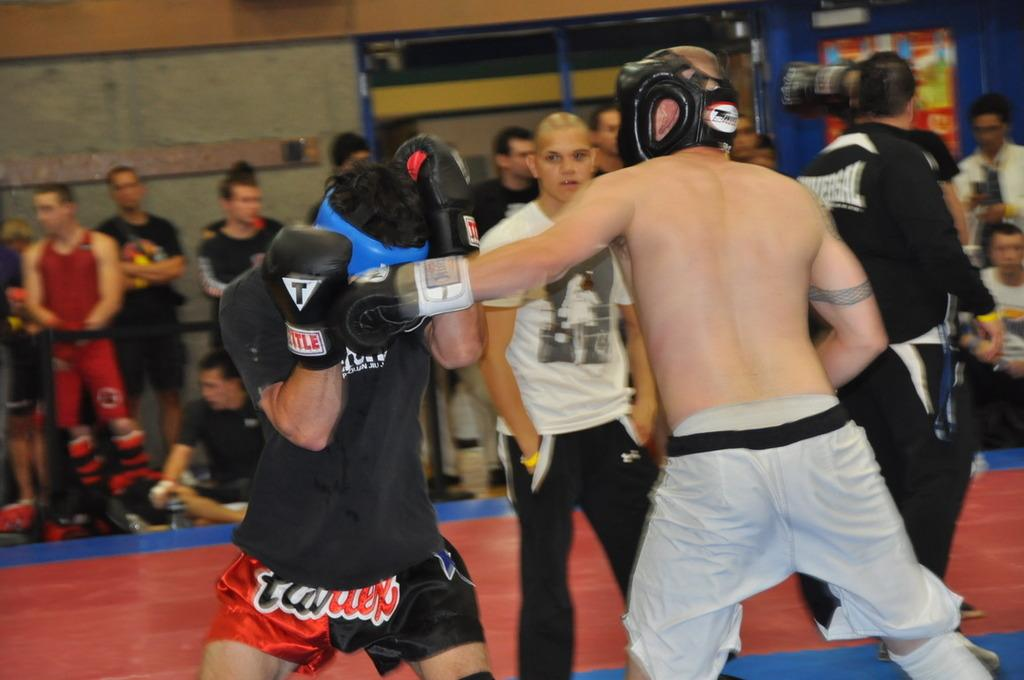What are the people in the image doing? There are people standing and sitting in the image. What can be seen in the background of the image? There is a wall in the background of the image. What is on the wall in the image? There is a banner on the wall. What type of sponge is being used to clean the banner in the image? There is no sponge present in the image, and the banner does not appear to be dirty or in need of cleaning. 